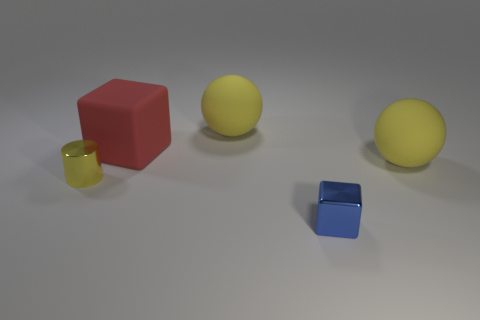What could be a possible scenario or story involving these objects? Imagine a playful setting in a child's room, where each item represents a character in their fantasy world. The red cube could be the sturdy house, the yellow rubber ducky, the beloved pet, the small metal cube a treasure box, the transparent cup a magical chalice, and the yellow sphere can be the sun or a golden ball to be retrieved in a heroic quest. 